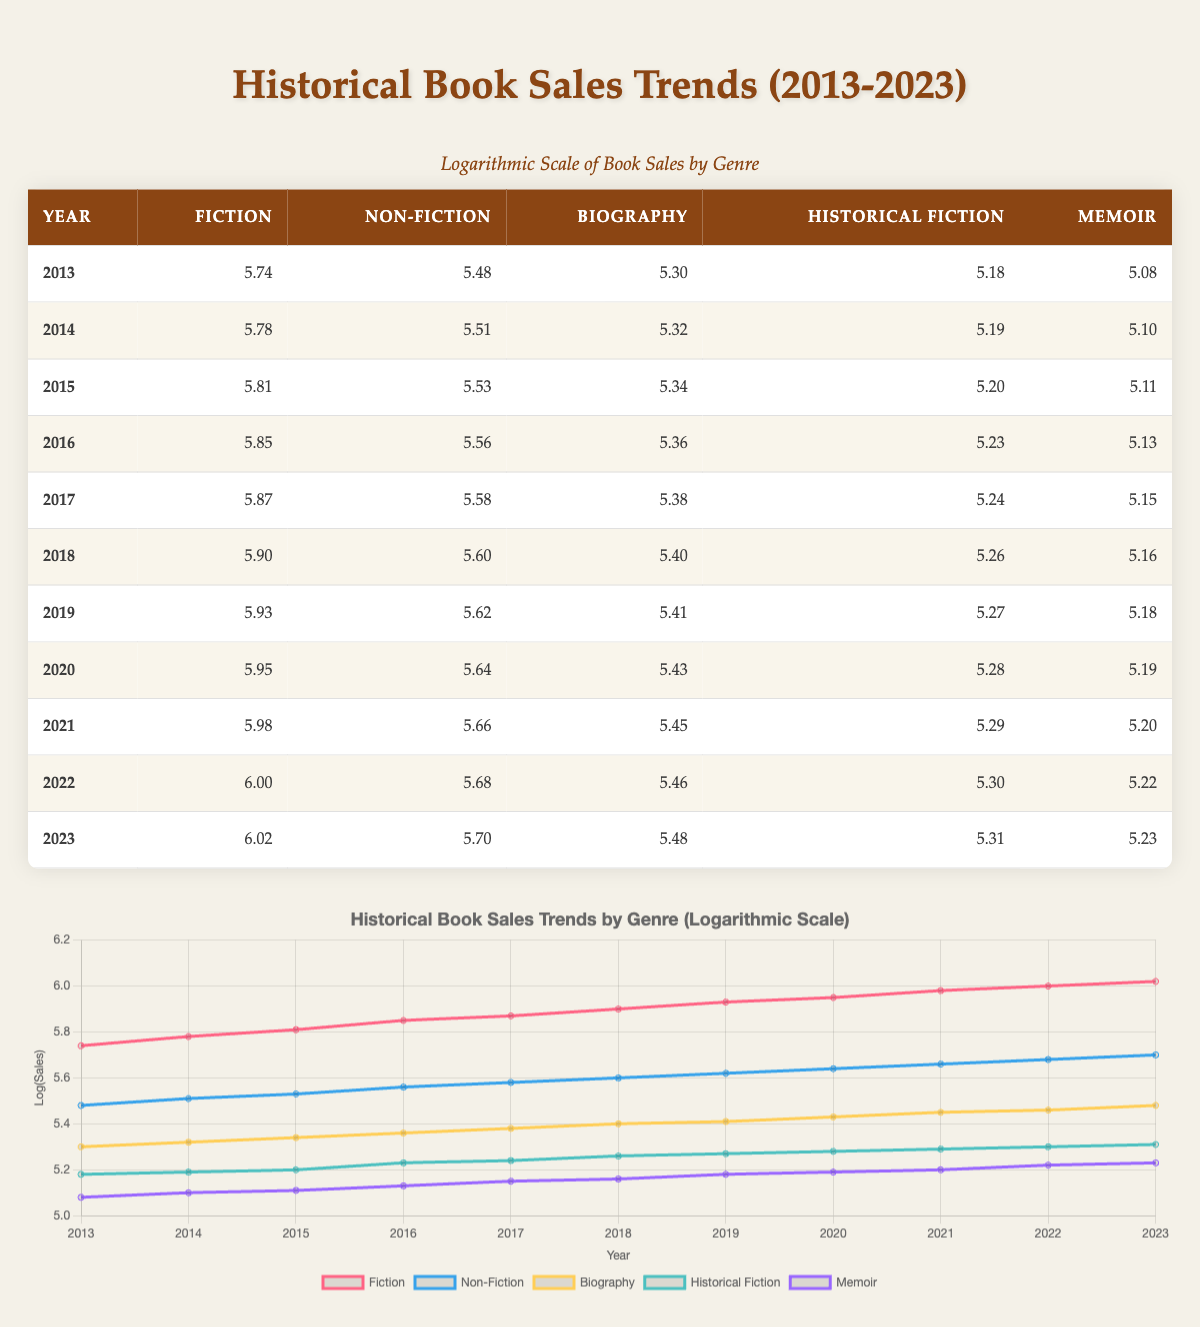What were the fiction book sales in 2015? The table indicates that the fiction book sales in 2015 were recorded as 5.81 on a logarithmic scale.
Answer: 5.81 What was the highest recorded sales for memoirs in the table? In the table, the highest sales for memoirs were 5.23, which occurred in 2023.
Answer: 5.23 Which genre showed a steady increase over the years? All genres in the table show an increase over the years, but fiction specifically had the highest growth from 5.74 in 2013 to 6.02 in 2023, indicating a consistent upward trend.
Answer: Yes What is the average logarithmic sales value for historical fiction from 2013 to 2023? To find the average, sum the values for historical fiction (5.18 + 5.19 + 5.20 + 5.23 + 5.24 + 5.26 + 5.27 + 5.28 + 5.29 + 5.30 + 5.31) which equals 57.06, and then divide by 11, resulting in an average of approximately 5.19.
Answer: 5.19 Was the sales of non-fiction books ever lower than 5.5 in the table? Reviewing the non-fiction values from 2013 to 2023, all values are above 5.5 starting from 5.48 in 2013, meaning it was never lower than 5.5.
Answer: No How much higher were the total sales of fiction compared to biography in 2022? In 2022, fiction sales were 6.00 and biography sales were 5.46. The difference is 6.00 - 5.46 = 0.54. Thus, fiction was higher by this amount.
Answer: 0.54 What trend can be observed in biography sales over the decade? By examining the table, biography sales increased steadily from 5.30 in 2013 to 5.48 in 2023, showing an upward trend in sales over the decade.
Answer: Yes Which genre had the lowest sales in 2019? In 2019, the memoir genre had the lowest sales at 5.18 compared to the other genres listed in the table.
Answer: Memoir What is the difference in sales between the highest and lowest genres in 2023? In 2023, fiction sales were 6.02 while memoir sales were 5.23. The difference is 6.02 - 5.23 = 0.79, showing the gap between the highest and lowest genre.
Answer: 0.79 